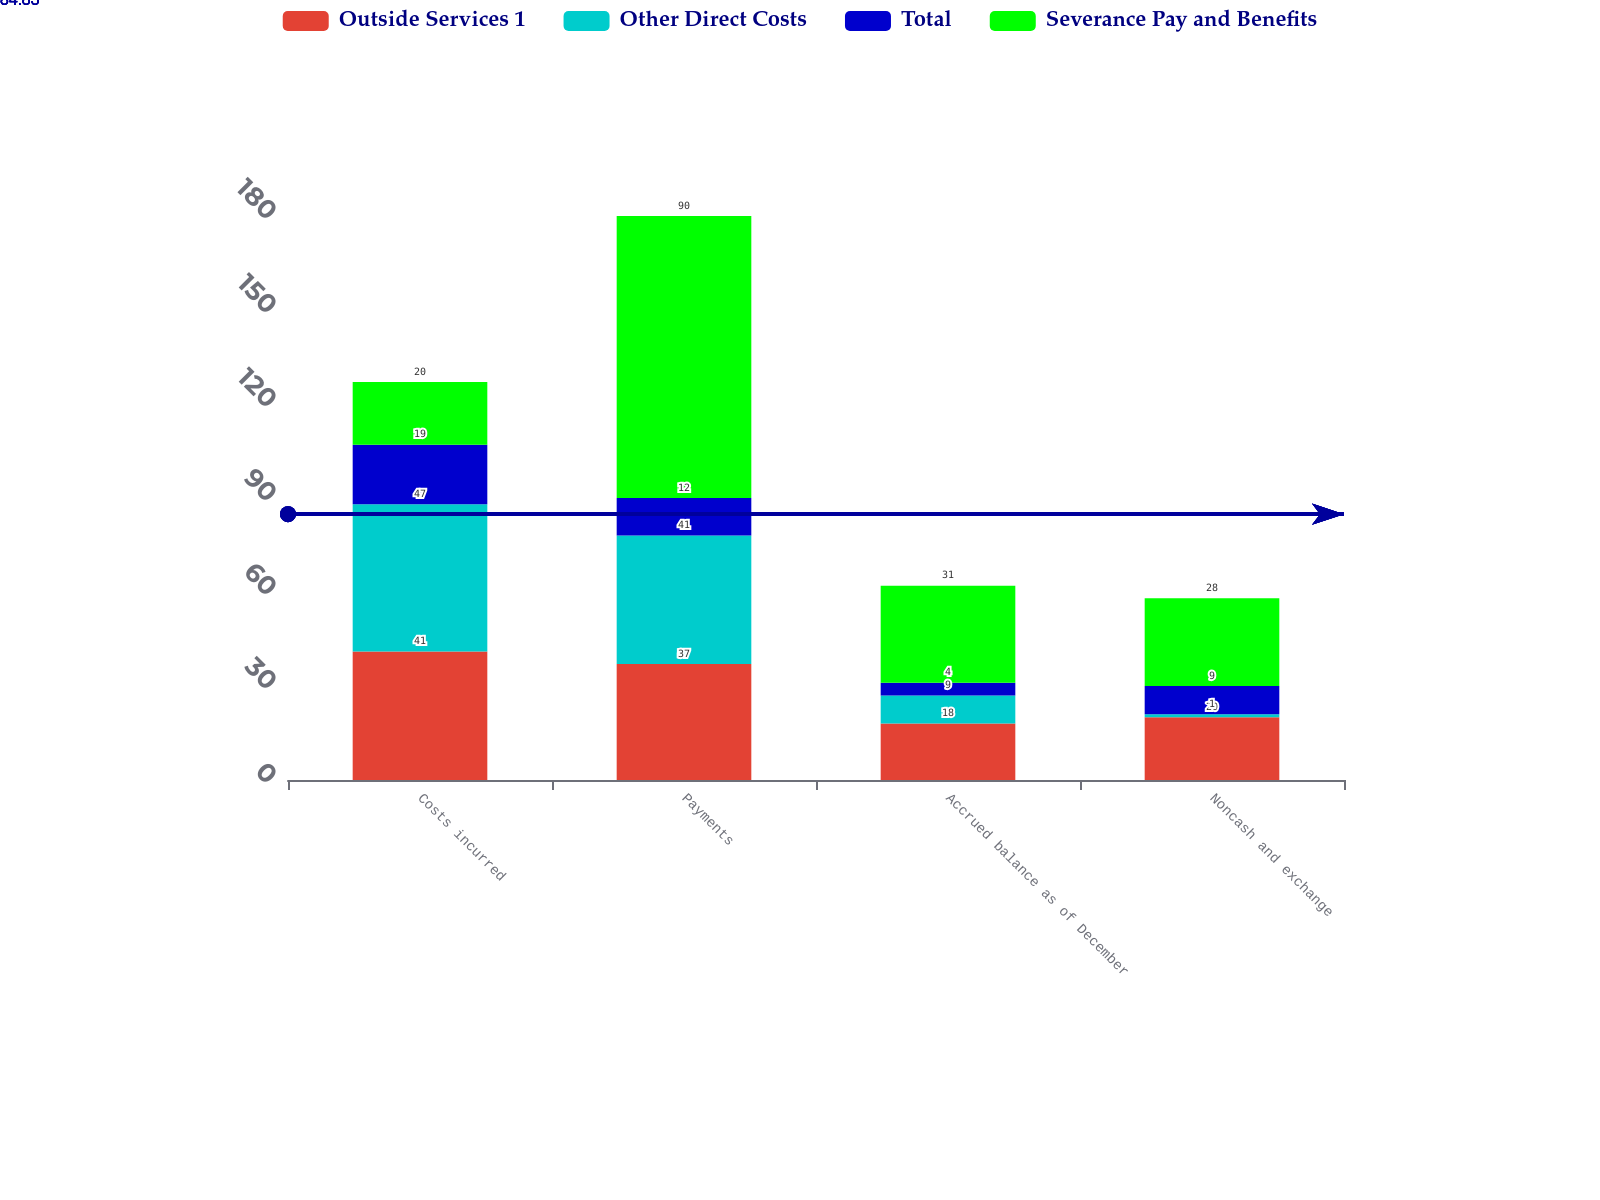Convert chart to OTSL. <chart><loc_0><loc_0><loc_500><loc_500><stacked_bar_chart><ecel><fcel>Costs incurred<fcel>Payments<fcel>Accrued balance as of December<fcel>Noncash and exchange<nl><fcel>Outside Services 1<fcel>41<fcel>37<fcel>18<fcel>20<nl><fcel>Other Direct Costs<fcel>47<fcel>41<fcel>9<fcel>1<nl><fcel>Total<fcel>19<fcel>12<fcel>4<fcel>9<nl><fcel>Severance Pay and Benefits<fcel>20<fcel>90<fcel>31<fcel>28<nl></chart> 